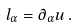<formula> <loc_0><loc_0><loc_500><loc_500>l _ { \alpha } = \partial _ { \alpha } u \, .</formula> 